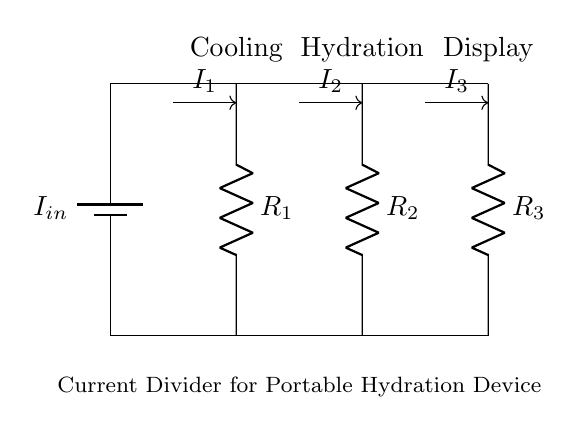What is the total current entering the circuit? The total current entering the circuit is given as I_in, which flows from the battery to the current divider.
Answer: I_in What components are present in the current divider? The components present in the current divider are the resistors R1, R2, and R3, which divide the input current into three separate paths.
Answer: R1, R2, R3 How many branches does the current divide into? The current divides into three branches, each connected to resistors R1, R2, and R3 respectively.
Answer: Three What is the function of R1 in the circuit? R1 acts as a resistive load that allows some portion of the input current I_in to flow through it for cooling purposes.
Answer: Cooling Which component is associated with hydration? The component associated with hydration is R2, which is the resistor designated for the hydration system, allowing part of the current to help power that function.
Answer: R2 What is the relationship between I_in and the branch currents? The current I_in is divided into three branch currents: I1, I2, and I3. According to the current divider rule, I_in equals the sum of I1, I2, and I3.
Answer: I_in = I1 + I2 + I3 Which resistor would have the highest current if they are of equal value? If all resistors R1, R2, and R3 have equal resistance, the current will split evenly across the resistors making each branch current equal. However, in practical applications, the connected device may change this distribution.
Answer: Equal currents 